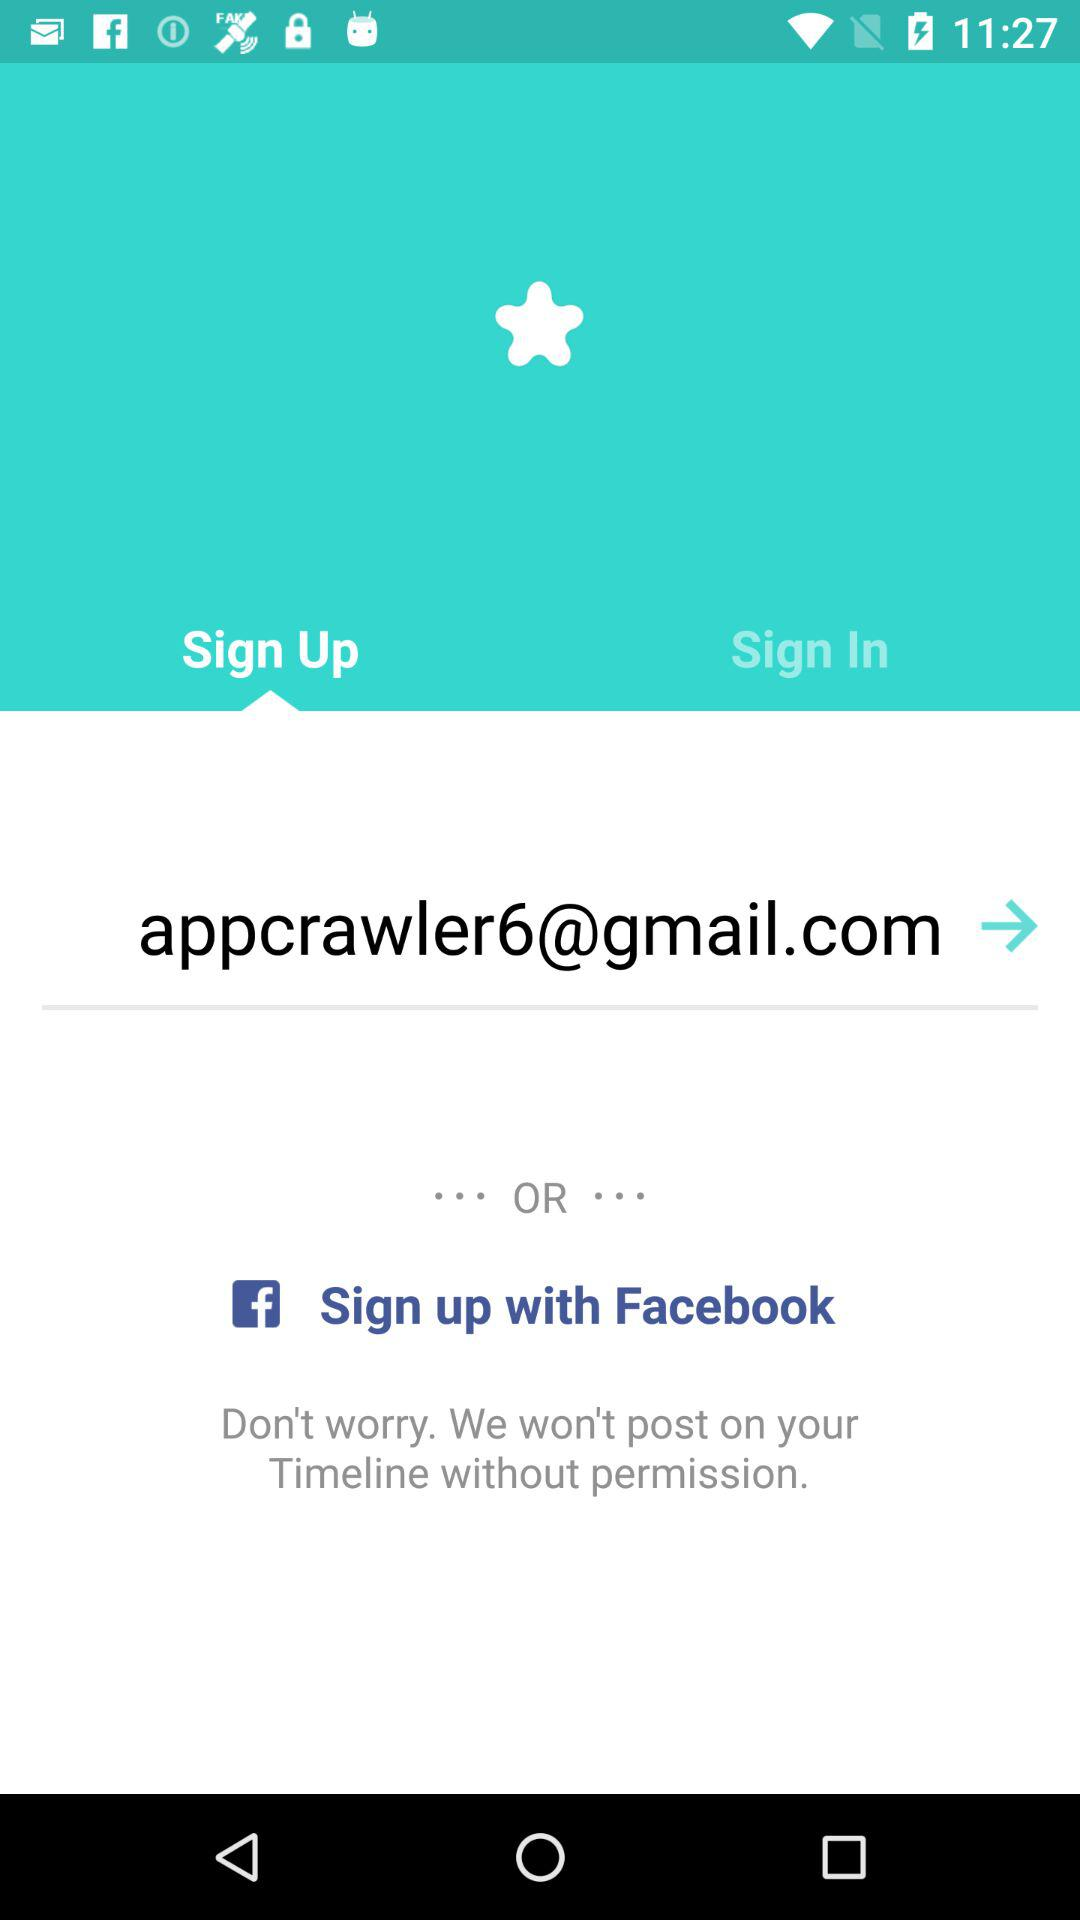What is the entered Gmail address? The entered Gmail address is appcrawler6@gmail.com. 